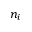<formula> <loc_0><loc_0><loc_500><loc_500>n _ { i }</formula> 